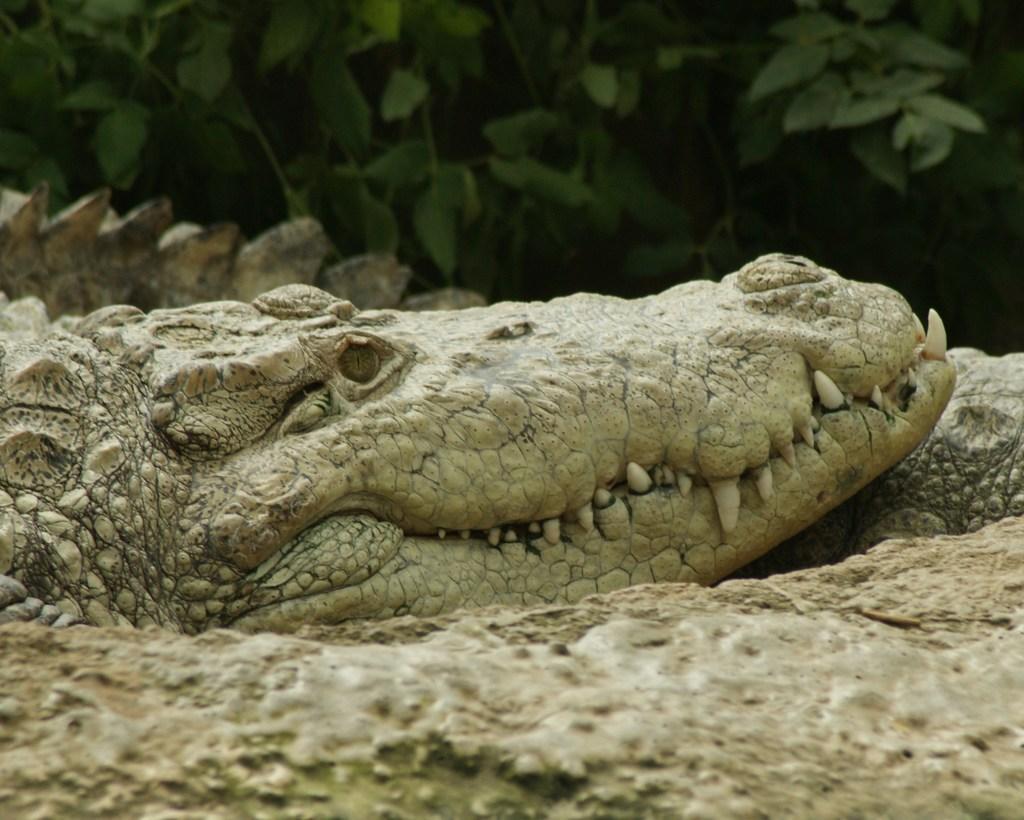How would you summarize this image in a sentence or two? In this picture we can see a crocodile on the ground and in the background we can see trees. 